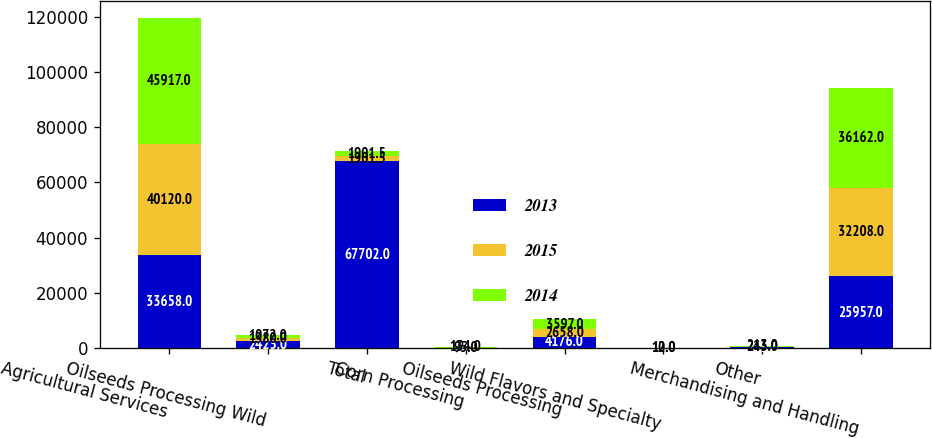Convert chart. <chart><loc_0><loc_0><loc_500><loc_500><stacked_bar_chart><ecel><fcel>Agricultural Services<fcel>Oilseeds Processing Wild<fcel>Total<fcel>Corn Processing<fcel>Oilseeds Processing<fcel>Wild Flavors and Specialty<fcel>Other<fcel>Merchandising and Handling<nl><fcel>2013<fcel>33658<fcel>2423<fcel>67702<fcel>56<fcel>4176<fcel>16<fcel>233<fcel>25957<nl><fcel>2015<fcel>40120<fcel>1380<fcel>1901.5<fcel>95<fcel>2658<fcel>12<fcel>243<fcel>32208<nl><fcel>2014<fcel>45917<fcel>1072<fcel>1901.5<fcel>134<fcel>3597<fcel>10<fcel>213<fcel>36162<nl></chart> 